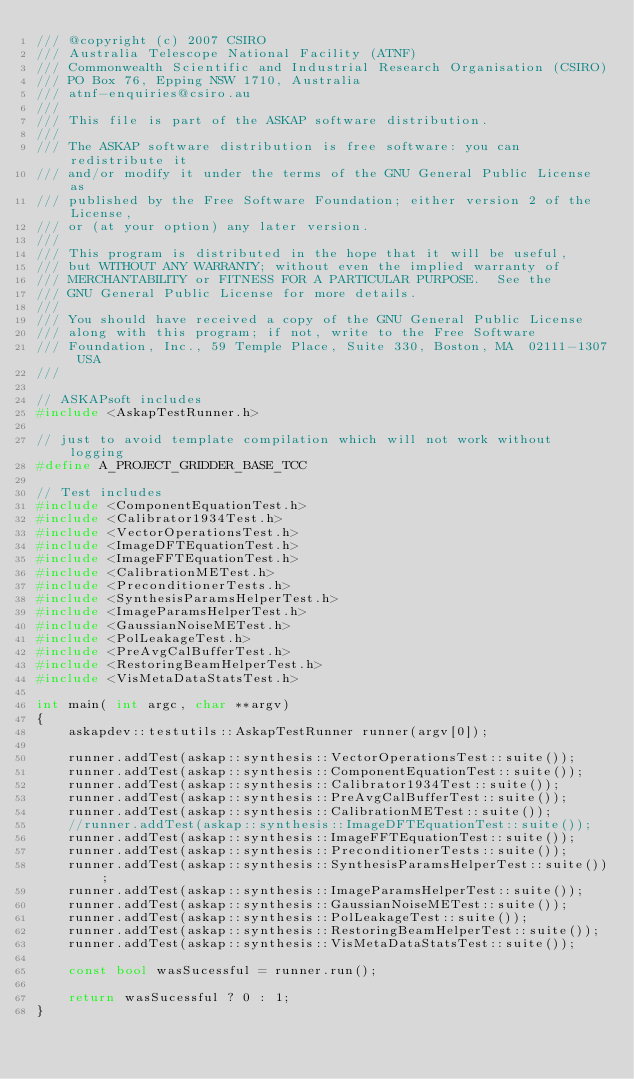<code> <loc_0><loc_0><loc_500><loc_500><_C++_>/// @copyright (c) 2007 CSIRO
/// Australia Telescope National Facility (ATNF)
/// Commonwealth Scientific and Industrial Research Organisation (CSIRO)
/// PO Box 76, Epping NSW 1710, Australia
/// atnf-enquiries@csiro.au
///
/// This file is part of the ASKAP software distribution.
///
/// The ASKAP software distribution is free software: you can redistribute it
/// and/or modify it under the terms of the GNU General Public License as
/// published by the Free Software Foundation; either version 2 of the License,
/// or (at your option) any later version.
///
/// This program is distributed in the hope that it will be useful,
/// but WITHOUT ANY WARRANTY; without even the implied warranty of
/// MERCHANTABILITY or FITNESS FOR A PARTICULAR PURPOSE.  See the
/// GNU General Public License for more details.
///
/// You should have received a copy of the GNU General Public License
/// along with this program; if not, write to the Free Software
/// Foundation, Inc., 59 Temple Place, Suite 330, Boston, MA  02111-1307 USA
///

// ASKAPsoft includes
#include <AskapTestRunner.h>

// just to avoid template compilation which will not work without logging
#define A_PROJECT_GRIDDER_BASE_TCC

// Test includes
#include <ComponentEquationTest.h>
#include <Calibrator1934Test.h>
#include <VectorOperationsTest.h>
#include <ImageDFTEquationTest.h>
#include <ImageFFTEquationTest.h>
#include <CalibrationMETest.h>
#include <PreconditionerTests.h>
#include <SynthesisParamsHelperTest.h>
#include <ImageParamsHelperTest.h>
#include <GaussianNoiseMETest.h>
#include <PolLeakageTest.h>
#include <PreAvgCalBufferTest.h>
#include <RestoringBeamHelperTest.h>
#include <VisMetaDataStatsTest.h>

int main( int argc, char **argv)
{
    askapdev::testutils::AskapTestRunner runner(argv[0]);

    runner.addTest(askap::synthesis::VectorOperationsTest::suite());
    runner.addTest(askap::synthesis::ComponentEquationTest::suite());
    runner.addTest(askap::synthesis::Calibrator1934Test::suite());
    runner.addTest(askap::synthesis::PreAvgCalBufferTest::suite());
    runner.addTest(askap::synthesis::CalibrationMETest::suite());
    //runner.addTest(askap::synthesis::ImageDFTEquationTest::suite());
    runner.addTest(askap::synthesis::ImageFFTEquationTest::suite());
    runner.addTest(askap::synthesis::PreconditionerTests::suite());
    runner.addTest(askap::synthesis::SynthesisParamsHelperTest::suite());
    runner.addTest(askap::synthesis::ImageParamsHelperTest::suite());
    runner.addTest(askap::synthesis::GaussianNoiseMETest::suite());
    runner.addTest(askap::synthesis::PolLeakageTest::suite());
    runner.addTest(askap::synthesis::RestoringBeamHelperTest::suite());
    runner.addTest(askap::synthesis::VisMetaDataStatsTest::suite());

    const bool wasSucessful = runner.run();

    return wasSucessful ? 0 : 1;
}
</code> 